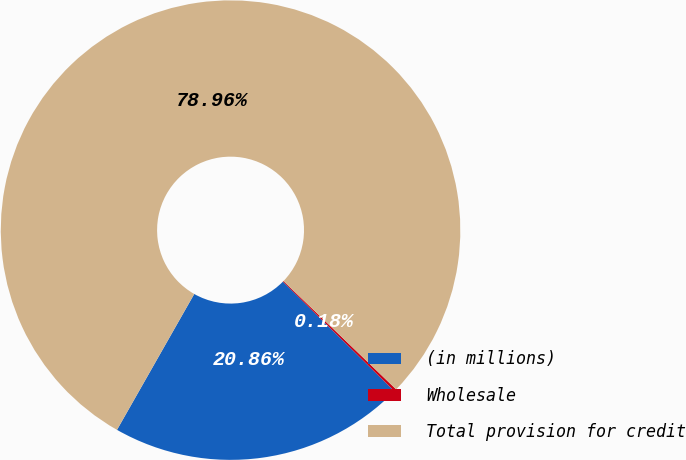Convert chart. <chart><loc_0><loc_0><loc_500><loc_500><pie_chart><fcel>(in millions)<fcel>Wholesale<fcel>Total provision for credit<nl><fcel>20.86%<fcel>0.18%<fcel>78.96%<nl></chart> 